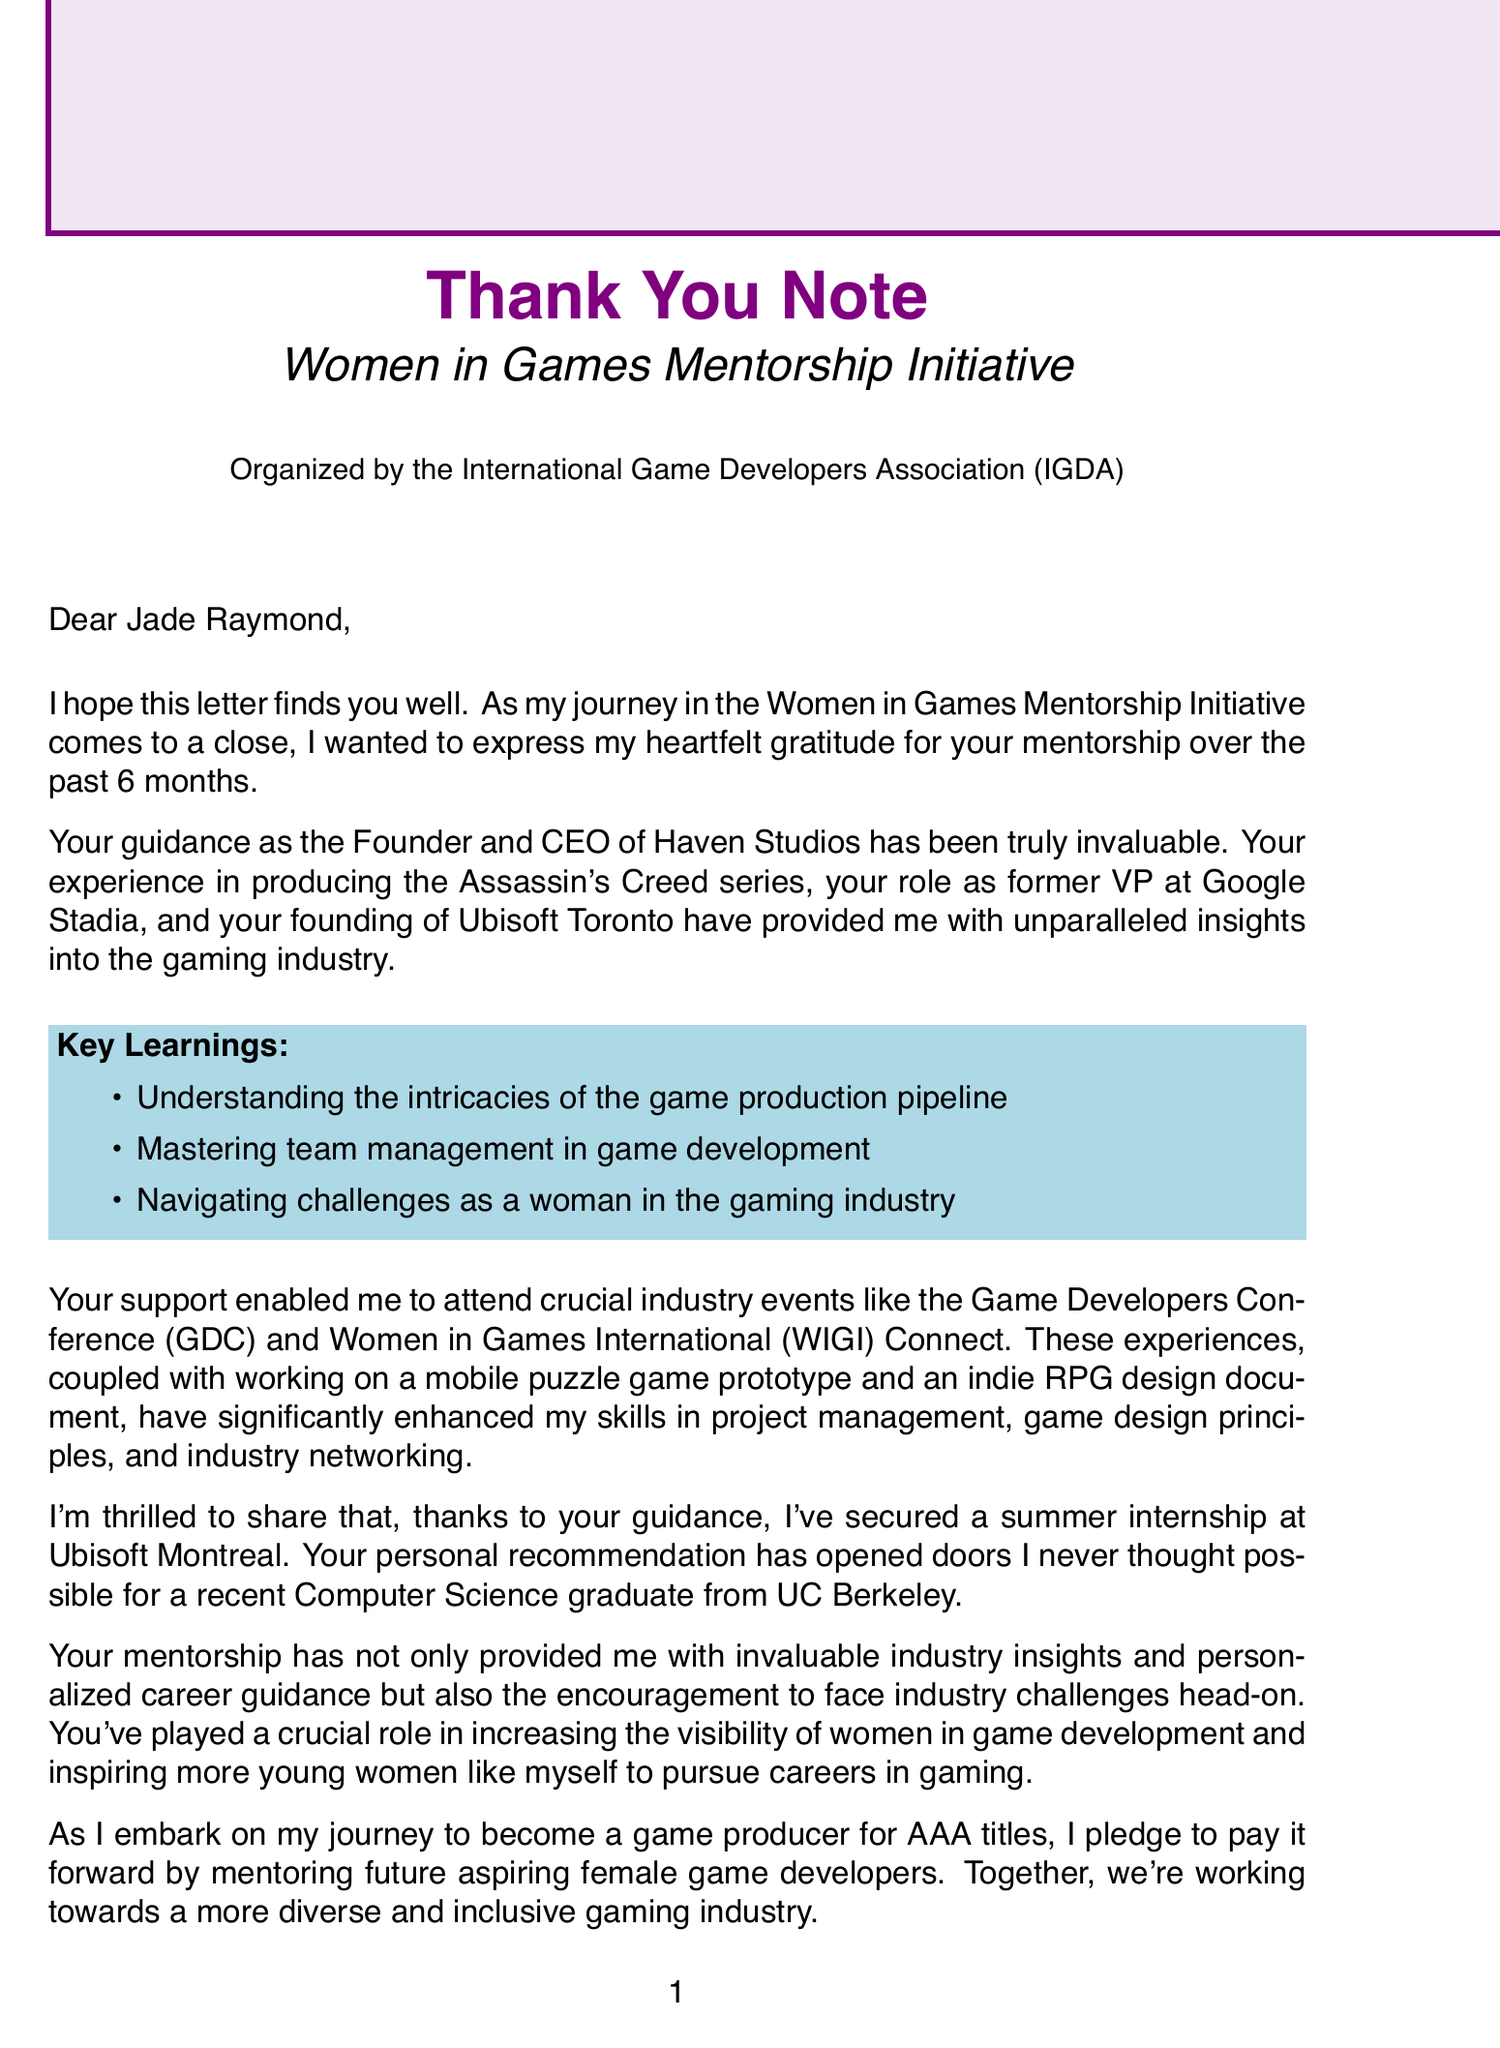What is the name of the mentorship program? The name of the mentorship program is indicated in the document as "Women in Games Mentorship Initiative."
Answer: Women in Games Mentorship Initiative Who is the mentor mentioned in the letter? The document specifies that the mentor's name is written as "Jade Raymond."
Answer: Jade Raymond How long did the mentorship program last? The duration of the program is stated as "6 months."
Answer: 6 months What is Sarah Chen's career goal? The document reveals that Sarah Chen's career goal is to "Become a game producer for AAA titles."
Answer: Become a game producer for AAA titles Which notable achievements does Jade Raymond have? The letter mentions several notable achievements, including producing the "Assassin's Creed series."
Answer: Produced Assassin's Creed series What specific skill improved during the mentorship? Among the skills mentioned, the document lists "Project management" as one that improved.
Answer: Project management What future opportunity did Sarah secure through the mentorship? The document states that Sarah secured a "Summer internship at Ubisoft Montreal."
Answer: Summer internship at Ubisoft Montreal What commitment does Sarah Chen make at the end of the letter? The letter conveys that Sarah Chen pledges "to mentor future aspiring female game developers."
Answer: To mentor future aspiring female game developers What industry event did Sarah attend? The document lists the "Game Developers Conference (GDC)" as an event Sarah attended.
Answer: Game Developers Conference (GDC) What impact does the mentorship aim to have on the industry? The document states the mentorship aims to "increase visibility of women in game development."
Answer: Increase visibility of women in game development 